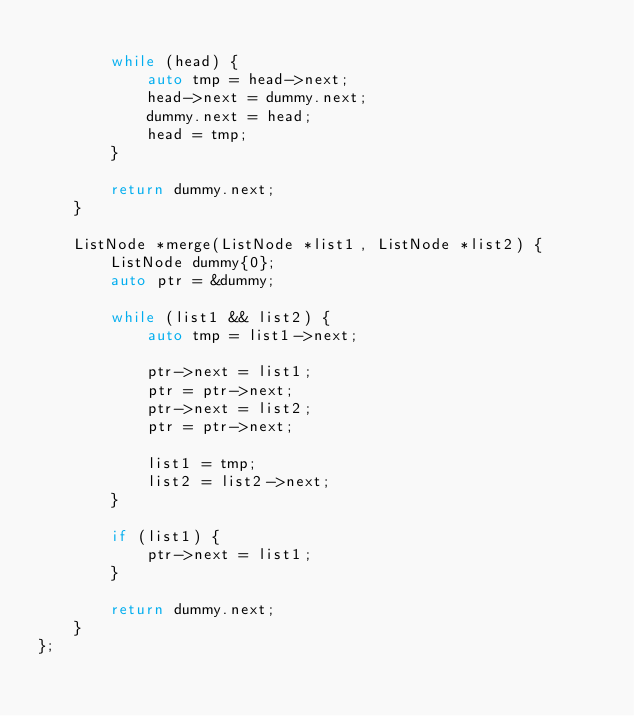<code> <loc_0><loc_0><loc_500><loc_500><_C++_>
        while (head) {
            auto tmp = head->next;
            head->next = dummy.next;
            dummy.next = head;
            head = tmp;
        }

        return dummy.next;
    }

    ListNode *merge(ListNode *list1, ListNode *list2) {
        ListNode dummy{0};
        auto ptr = &dummy;

        while (list1 && list2) {
            auto tmp = list1->next;

            ptr->next = list1;
            ptr = ptr->next;
            ptr->next = list2;
            ptr = ptr->next;

            list1 = tmp;
            list2 = list2->next;
        }

        if (list1) {
            ptr->next = list1;
        }

        return dummy.next;
    }
};
</code> 